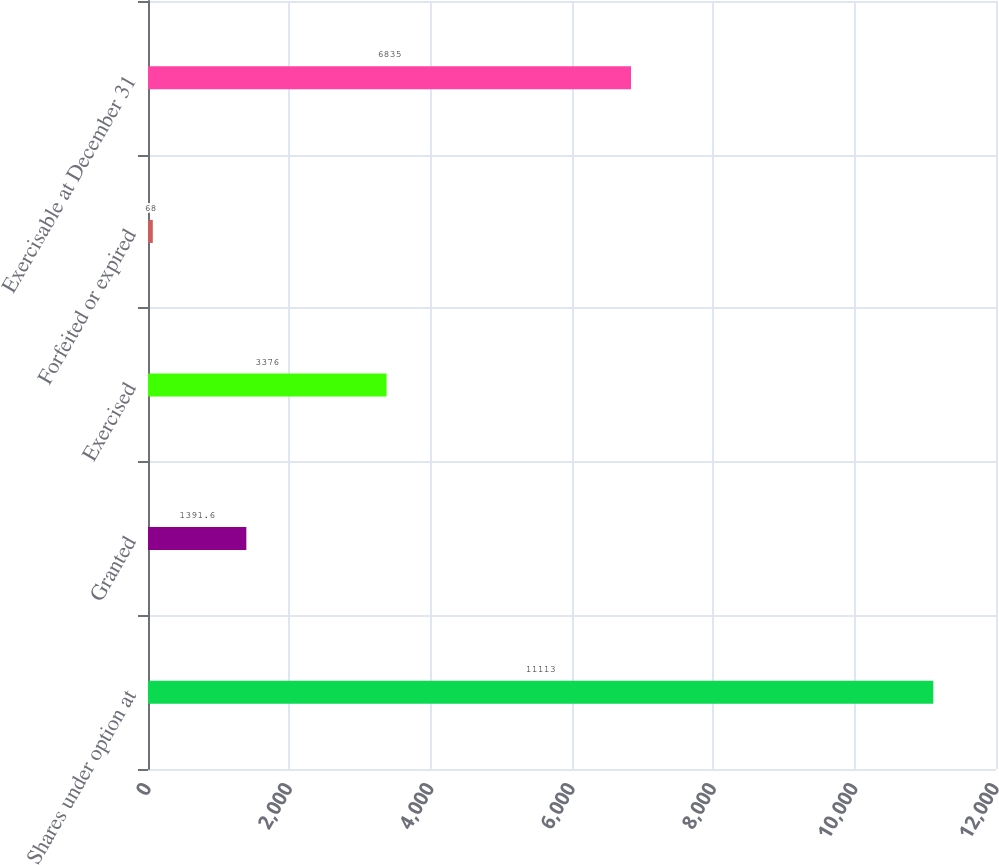Convert chart to OTSL. <chart><loc_0><loc_0><loc_500><loc_500><bar_chart><fcel>Shares under option at<fcel>Granted<fcel>Exercised<fcel>Forfeited or expired<fcel>Exercisable at December 31<nl><fcel>11113<fcel>1391.6<fcel>3376<fcel>68<fcel>6835<nl></chart> 